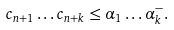<formula> <loc_0><loc_0><loc_500><loc_500>c _ { n + 1 } \dots c _ { n + k } \leq \alpha _ { 1 } \dots \alpha _ { k } ^ { - } .</formula> 